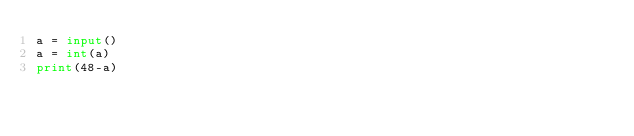<code> <loc_0><loc_0><loc_500><loc_500><_Python_>a = input()
a = int(a)
print(48-a)</code> 